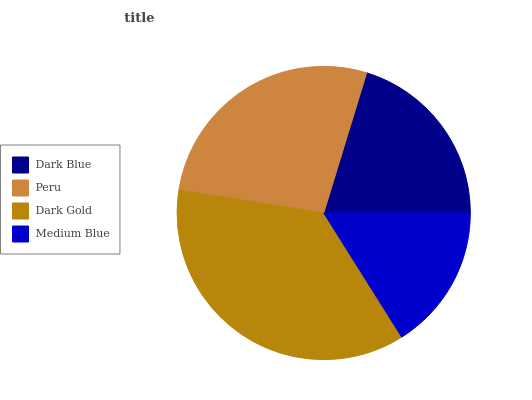Is Medium Blue the minimum?
Answer yes or no. Yes. Is Dark Gold the maximum?
Answer yes or no. Yes. Is Peru the minimum?
Answer yes or no. No. Is Peru the maximum?
Answer yes or no. No. Is Peru greater than Dark Blue?
Answer yes or no. Yes. Is Dark Blue less than Peru?
Answer yes or no. Yes. Is Dark Blue greater than Peru?
Answer yes or no. No. Is Peru less than Dark Blue?
Answer yes or no. No. Is Peru the high median?
Answer yes or no. Yes. Is Dark Blue the low median?
Answer yes or no. Yes. Is Medium Blue the high median?
Answer yes or no. No. Is Dark Gold the low median?
Answer yes or no. No. 